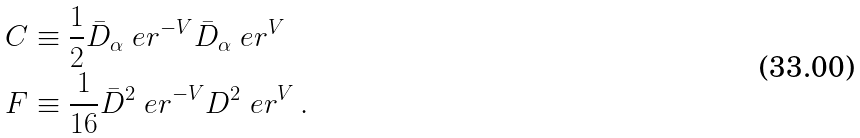Convert formula to latex. <formula><loc_0><loc_0><loc_500><loc_500>& C \equiv \frac { 1 } { 2 } \bar { D } _ { \alpha } \ e r ^ { - V } \bar { D } _ { \alpha } \ e r ^ { V } \\ & F \equiv \frac { 1 } { 1 6 } \bar { D } ^ { 2 } \ e r ^ { - V } D ^ { 2 } \ e r ^ { V } \, .</formula> 